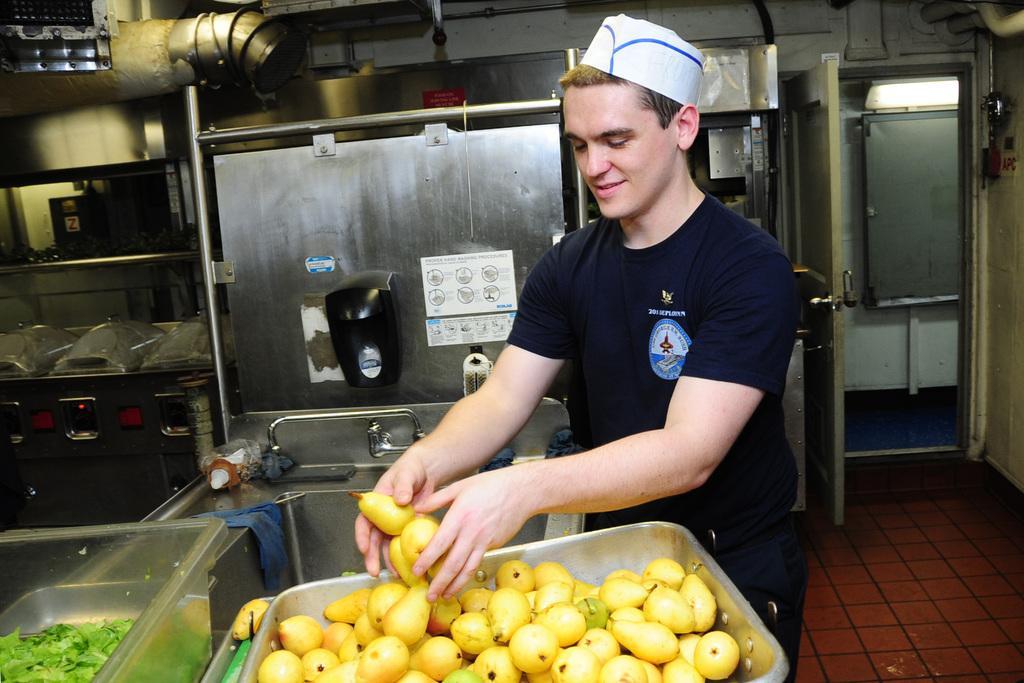Describe this image in one or two sentences. In this picture we can see a person holding some fruits and in front of him there is a tray with some fruits and we can see some other objects. There is a door on the right side and we can see some machine which looks like a oven in the background. 